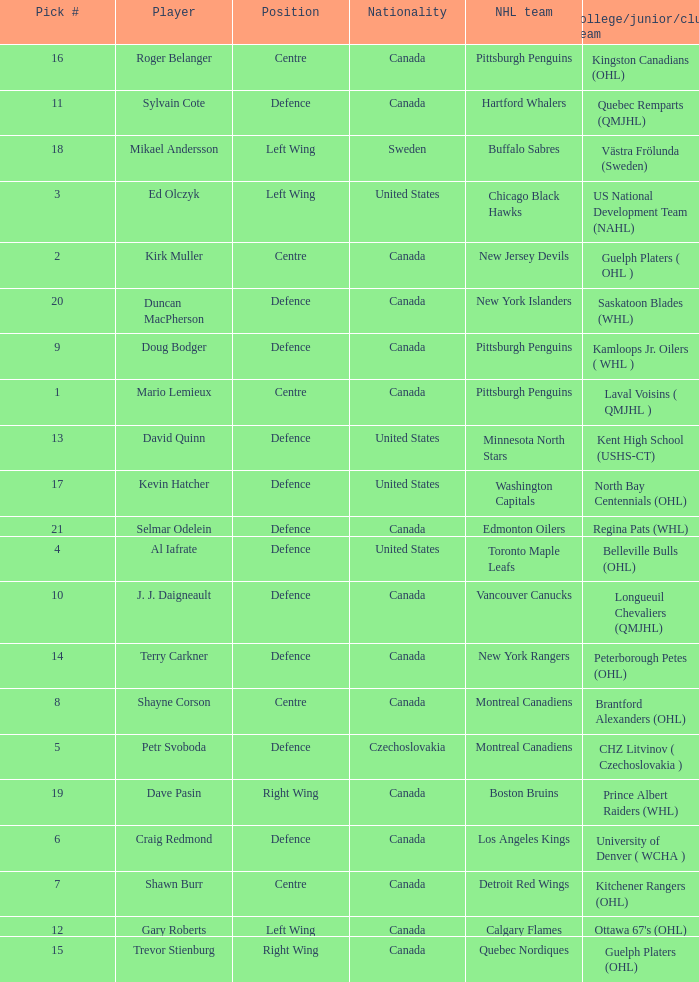What daft pick number is the player coming from Regina Pats (WHL)? 21.0. 